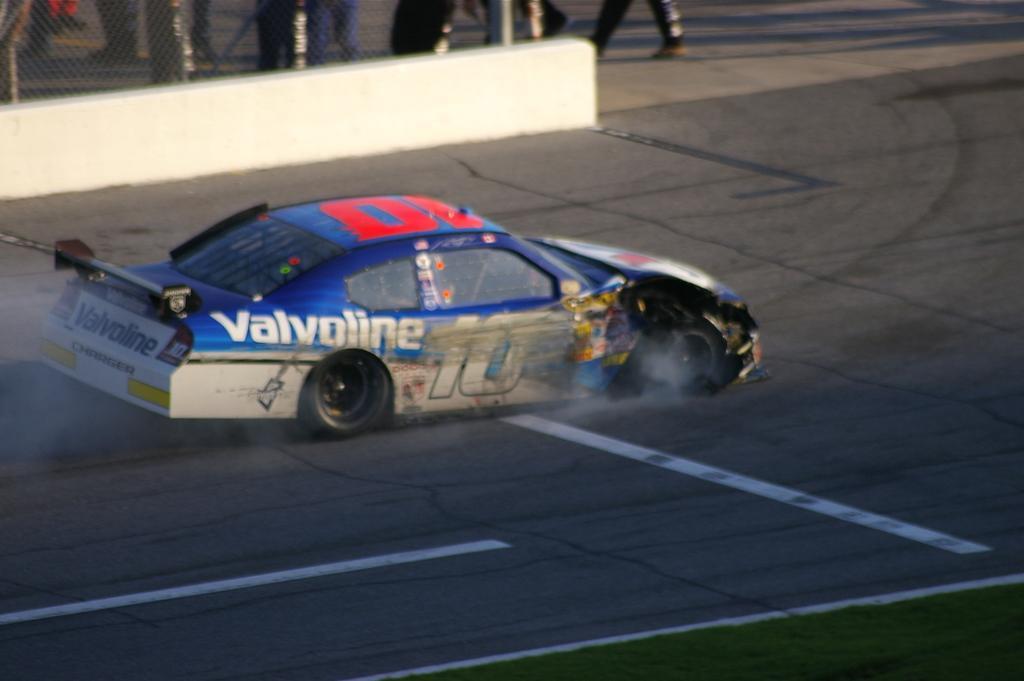Could you give a brief overview of what you see in this image? In this image we can see a car on the road and at the bottom we can see grass on the ground. In the background we can see fence and few persons are walking on the road but we can see only their legs. 